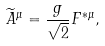<formula> <loc_0><loc_0><loc_500><loc_500>\widetilde { A } ^ { \mu } = \frac { g } { \sqrt { 2 } } F ^ { * \mu } ,</formula> 